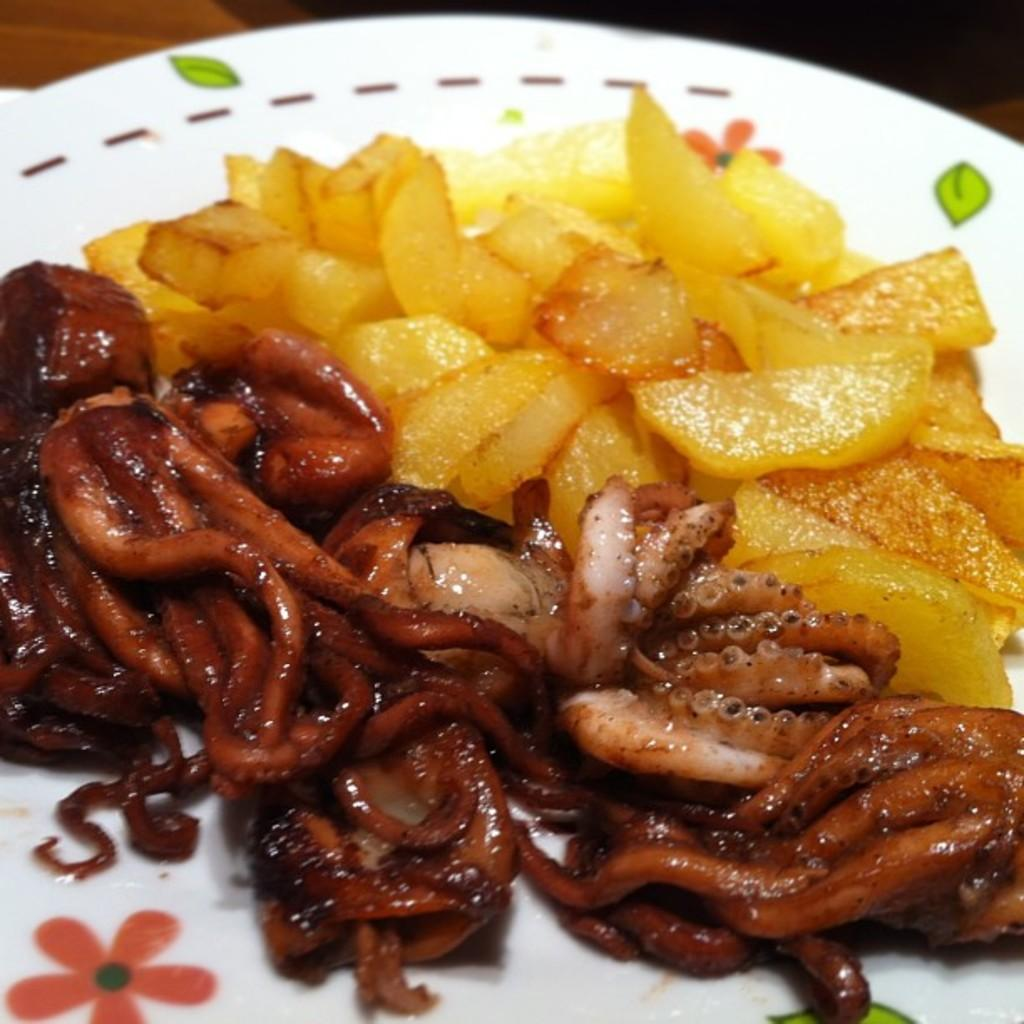What is the color of the plate in the image? The plate in the image is white. What is on the plate? There is food on the plate. What colors can be seen in the food? The food has yellow, white, and brown colors. How many flowers are on the plate in the image? There are no flowers present on the plate in the image. 